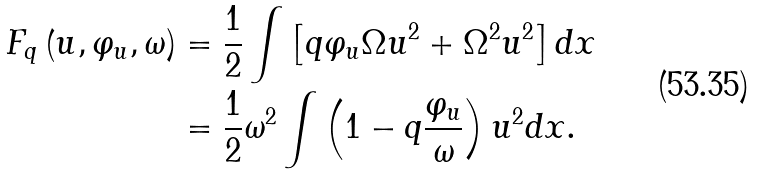Convert formula to latex. <formula><loc_0><loc_0><loc_500><loc_500>F _ { q } \left ( u , \varphi _ { u } , \omega \right ) & = \frac { 1 } { 2 } \int \left [ q \varphi _ { u } \Omega u ^ { 2 } + \Omega ^ { 2 } u ^ { 2 } \right ] d x \\ & = \frac { 1 } { 2 } \omega ^ { 2 } \int \left ( 1 - q \frac { \varphi _ { u } } { \omega } \right ) u ^ { 2 } d x .</formula> 